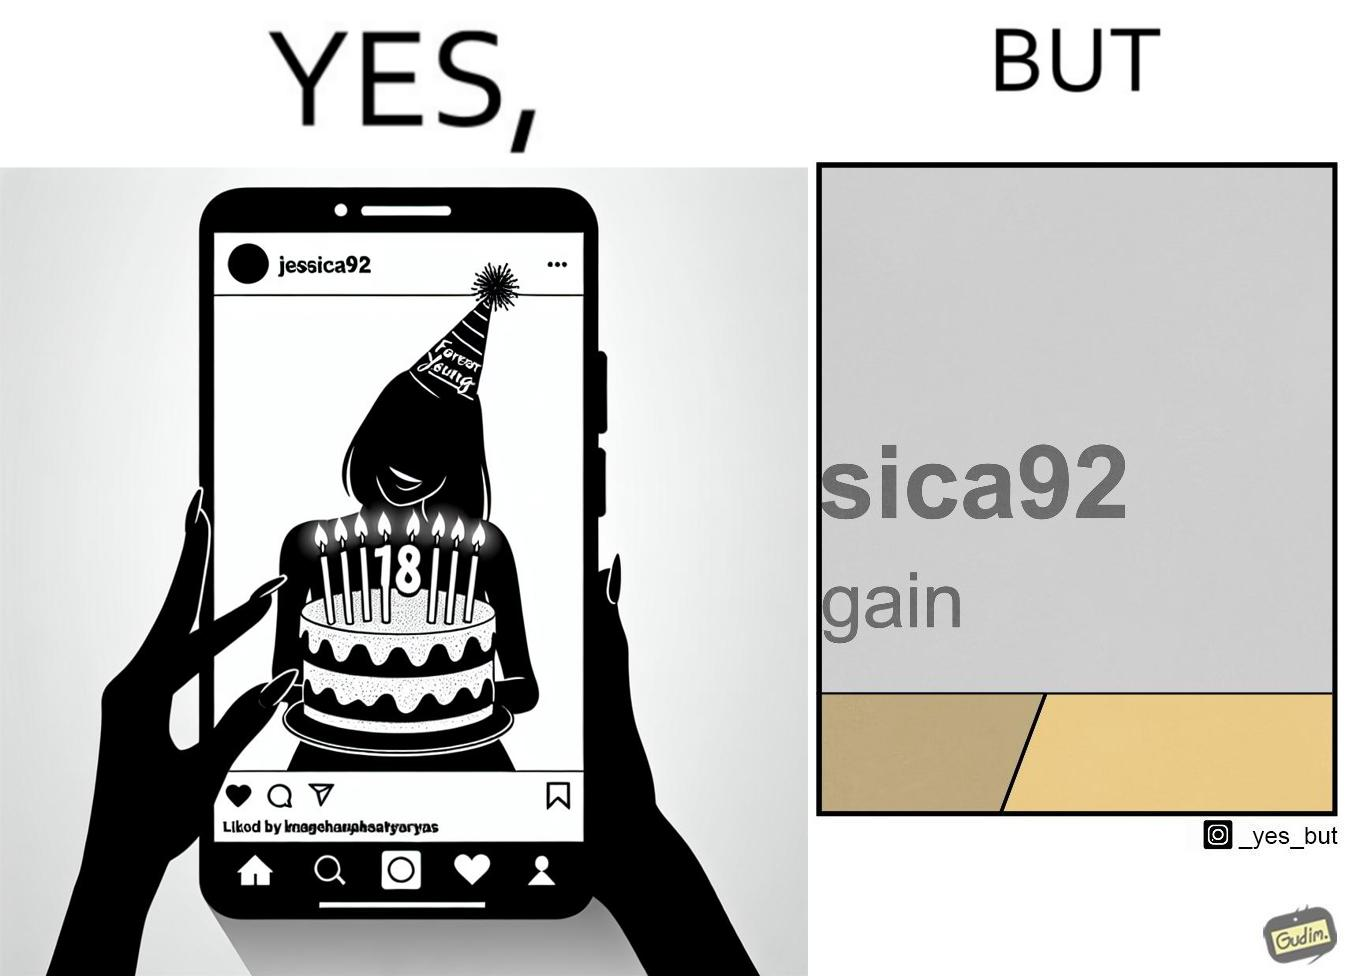What is shown in the left half versus the right half of this image? In the left part of the image: The image shows a photo of a woman shared on an instagram like social media platform. The handle name of the profile that has shared the photo is "jessica92" and the text below her handle says "18 again". In the shared photo is a woman celebrating her birthday. She is holding a cake with lit candles saying "Forever Young". She is also wearing a celebration cone on her head. In the right part of the image: The image shows texts "sica92" and "gain" with the former above the latter. 